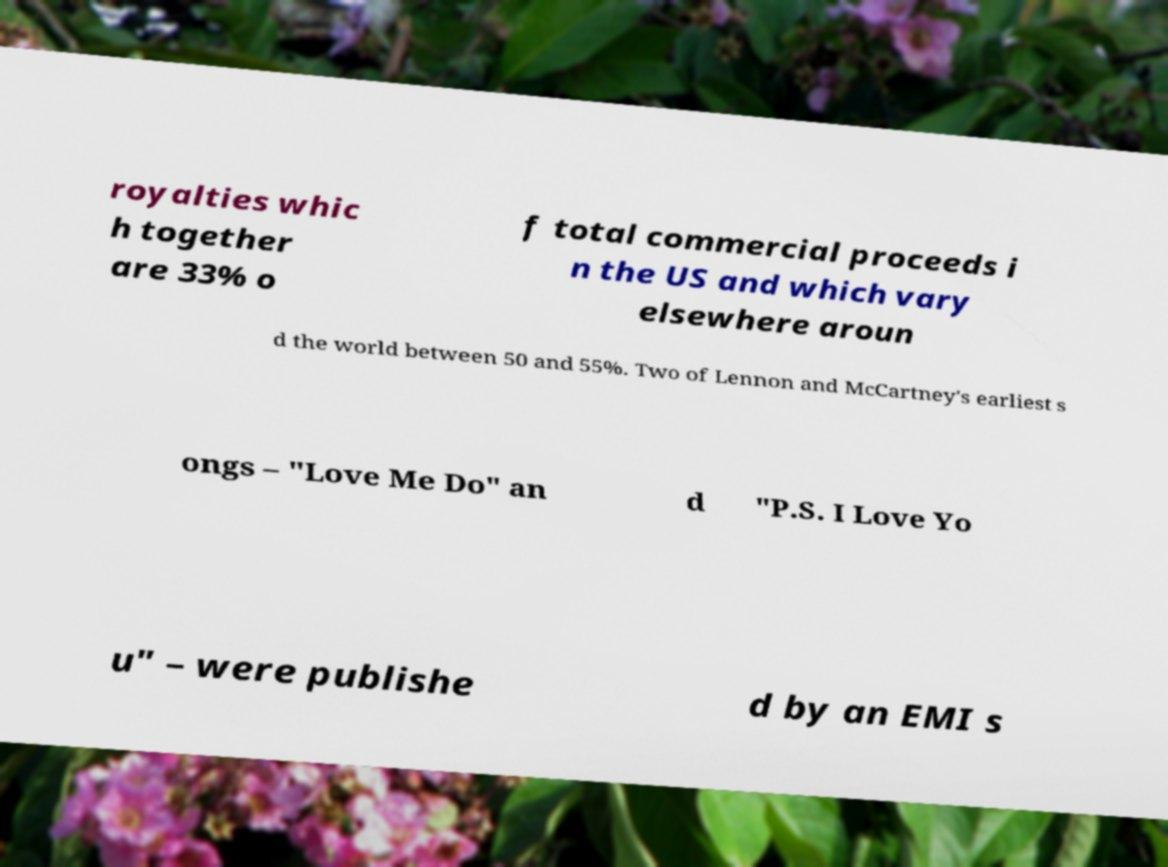Can you read and provide the text displayed in the image?This photo seems to have some interesting text. Can you extract and type it out for me? royalties whic h together are 33% o f total commercial proceeds i n the US and which vary elsewhere aroun d the world between 50 and 55%. Two of Lennon and McCartney's earliest s ongs – "Love Me Do" an d "P.S. I Love Yo u" – were publishe d by an EMI s 